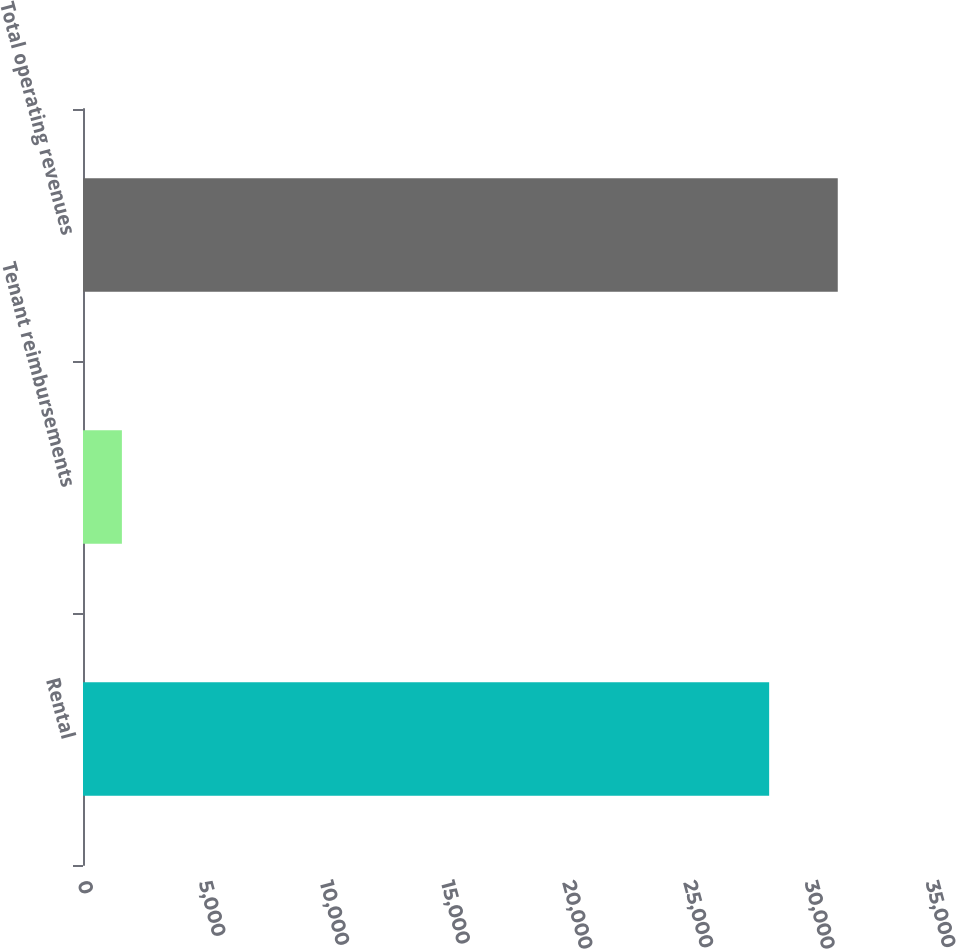Convert chart. <chart><loc_0><loc_0><loc_500><loc_500><bar_chart><fcel>Rental<fcel>Tenant reimbursements<fcel>Total operating revenues<nl><fcel>28320<fcel>1605<fcel>31152<nl></chart> 